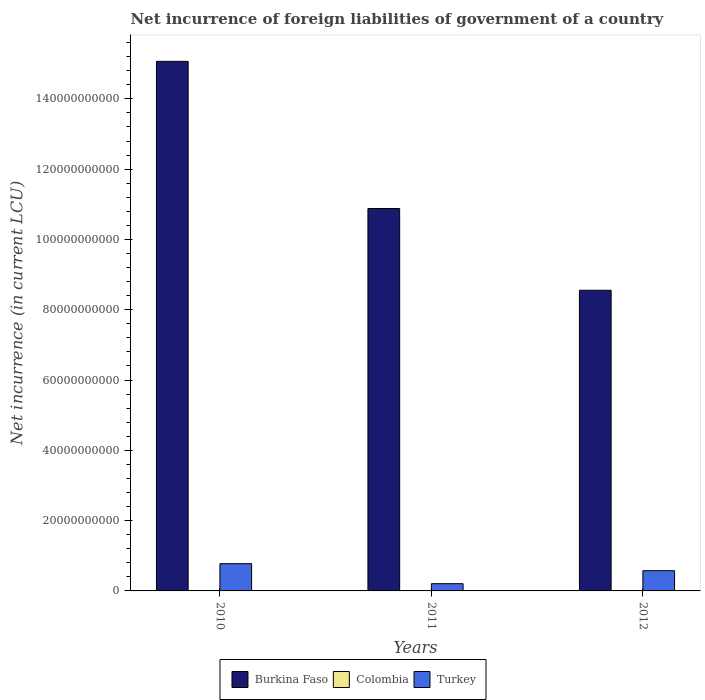How many different coloured bars are there?
Offer a very short reply. 2. How many bars are there on the 1st tick from the left?
Provide a short and direct response. 2. How many bars are there on the 1st tick from the right?
Ensure brevity in your answer.  2. What is the label of the 2nd group of bars from the left?
Provide a short and direct response. 2011. What is the net incurrence of foreign liabilities in Turkey in 2012?
Your answer should be compact. 5.76e+09. Across all years, what is the maximum net incurrence of foreign liabilities in Burkina Faso?
Ensure brevity in your answer.  1.51e+11. Across all years, what is the minimum net incurrence of foreign liabilities in Burkina Faso?
Your answer should be compact. 8.55e+1. What is the total net incurrence of foreign liabilities in Colombia in the graph?
Provide a short and direct response. 0. What is the difference between the net incurrence of foreign liabilities in Burkina Faso in 2010 and that in 2011?
Ensure brevity in your answer.  4.19e+1. What is the difference between the net incurrence of foreign liabilities in Turkey in 2011 and the net incurrence of foreign liabilities in Burkina Faso in 2010?
Ensure brevity in your answer.  -1.49e+11. What is the average net incurrence of foreign liabilities in Colombia per year?
Your response must be concise. 0. In the year 2011, what is the difference between the net incurrence of foreign liabilities in Burkina Faso and net incurrence of foreign liabilities in Turkey?
Offer a terse response. 1.07e+11. What is the ratio of the net incurrence of foreign liabilities in Burkina Faso in 2010 to that in 2011?
Provide a succinct answer. 1.38. What is the difference between the highest and the second highest net incurrence of foreign liabilities in Turkey?
Keep it short and to the point. 1.99e+09. What is the difference between the highest and the lowest net incurrence of foreign liabilities in Burkina Faso?
Your response must be concise. 6.51e+1. Are all the bars in the graph horizontal?
Offer a very short reply. No. How many years are there in the graph?
Make the answer very short. 3. What is the difference between two consecutive major ticks on the Y-axis?
Ensure brevity in your answer.  2.00e+1. Are the values on the major ticks of Y-axis written in scientific E-notation?
Ensure brevity in your answer.  No. Does the graph contain grids?
Offer a terse response. No. What is the title of the graph?
Your answer should be compact. Net incurrence of foreign liabilities of government of a country. What is the label or title of the Y-axis?
Provide a short and direct response. Net incurrence (in current LCU). What is the Net incurrence (in current LCU) of Burkina Faso in 2010?
Your answer should be very brief. 1.51e+11. What is the Net incurrence (in current LCU) of Colombia in 2010?
Provide a short and direct response. 0. What is the Net incurrence (in current LCU) of Turkey in 2010?
Offer a very short reply. 7.75e+09. What is the Net incurrence (in current LCU) of Burkina Faso in 2011?
Ensure brevity in your answer.  1.09e+11. What is the Net incurrence (in current LCU) of Turkey in 2011?
Make the answer very short. 2.06e+09. What is the Net incurrence (in current LCU) of Burkina Faso in 2012?
Ensure brevity in your answer.  8.55e+1. What is the Net incurrence (in current LCU) of Colombia in 2012?
Make the answer very short. 0. What is the Net incurrence (in current LCU) of Turkey in 2012?
Provide a succinct answer. 5.76e+09. Across all years, what is the maximum Net incurrence (in current LCU) in Burkina Faso?
Provide a succinct answer. 1.51e+11. Across all years, what is the maximum Net incurrence (in current LCU) in Turkey?
Make the answer very short. 7.75e+09. Across all years, what is the minimum Net incurrence (in current LCU) of Burkina Faso?
Provide a succinct answer. 8.55e+1. Across all years, what is the minimum Net incurrence (in current LCU) in Turkey?
Keep it short and to the point. 2.06e+09. What is the total Net incurrence (in current LCU) of Burkina Faso in the graph?
Your answer should be compact. 3.45e+11. What is the total Net incurrence (in current LCU) of Colombia in the graph?
Make the answer very short. 0. What is the total Net incurrence (in current LCU) in Turkey in the graph?
Offer a terse response. 1.56e+1. What is the difference between the Net incurrence (in current LCU) of Burkina Faso in 2010 and that in 2011?
Provide a succinct answer. 4.19e+1. What is the difference between the Net incurrence (in current LCU) in Turkey in 2010 and that in 2011?
Provide a short and direct response. 5.69e+09. What is the difference between the Net incurrence (in current LCU) in Burkina Faso in 2010 and that in 2012?
Make the answer very short. 6.51e+1. What is the difference between the Net incurrence (in current LCU) in Turkey in 2010 and that in 2012?
Your response must be concise. 1.99e+09. What is the difference between the Net incurrence (in current LCU) of Burkina Faso in 2011 and that in 2012?
Ensure brevity in your answer.  2.33e+1. What is the difference between the Net incurrence (in current LCU) of Turkey in 2011 and that in 2012?
Offer a very short reply. -3.70e+09. What is the difference between the Net incurrence (in current LCU) of Burkina Faso in 2010 and the Net incurrence (in current LCU) of Turkey in 2011?
Offer a very short reply. 1.49e+11. What is the difference between the Net incurrence (in current LCU) in Burkina Faso in 2010 and the Net incurrence (in current LCU) in Turkey in 2012?
Ensure brevity in your answer.  1.45e+11. What is the difference between the Net incurrence (in current LCU) of Burkina Faso in 2011 and the Net incurrence (in current LCU) of Turkey in 2012?
Your answer should be very brief. 1.03e+11. What is the average Net incurrence (in current LCU) in Burkina Faso per year?
Your answer should be compact. 1.15e+11. What is the average Net incurrence (in current LCU) in Turkey per year?
Give a very brief answer. 5.19e+09. In the year 2010, what is the difference between the Net incurrence (in current LCU) of Burkina Faso and Net incurrence (in current LCU) of Turkey?
Provide a succinct answer. 1.43e+11. In the year 2011, what is the difference between the Net incurrence (in current LCU) of Burkina Faso and Net incurrence (in current LCU) of Turkey?
Your response must be concise. 1.07e+11. In the year 2012, what is the difference between the Net incurrence (in current LCU) of Burkina Faso and Net incurrence (in current LCU) of Turkey?
Provide a succinct answer. 7.98e+1. What is the ratio of the Net incurrence (in current LCU) in Burkina Faso in 2010 to that in 2011?
Your response must be concise. 1.38. What is the ratio of the Net incurrence (in current LCU) in Turkey in 2010 to that in 2011?
Ensure brevity in your answer.  3.76. What is the ratio of the Net incurrence (in current LCU) in Burkina Faso in 2010 to that in 2012?
Offer a very short reply. 1.76. What is the ratio of the Net incurrence (in current LCU) of Turkey in 2010 to that in 2012?
Your response must be concise. 1.35. What is the ratio of the Net incurrence (in current LCU) of Burkina Faso in 2011 to that in 2012?
Provide a succinct answer. 1.27. What is the ratio of the Net incurrence (in current LCU) in Turkey in 2011 to that in 2012?
Ensure brevity in your answer.  0.36. What is the difference between the highest and the second highest Net incurrence (in current LCU) in Burkina Faso?
Keep it short and to the point. 4.19e+1. What is the difference between the highest and the second highest Net incurrence (in current LCU) of Turkey?
Keep it short and to the point. 1.99e+09. What is the difference between the highest and the lowest Net incurrence (in current LCU) in Burkina Faso?
Provide a short and direct response. 6.51e+1. What is the difference between the highest and the lowest Net incurrence (in current LCU) in Turkey?
Keep it short and to the point. 5.69e+09. 